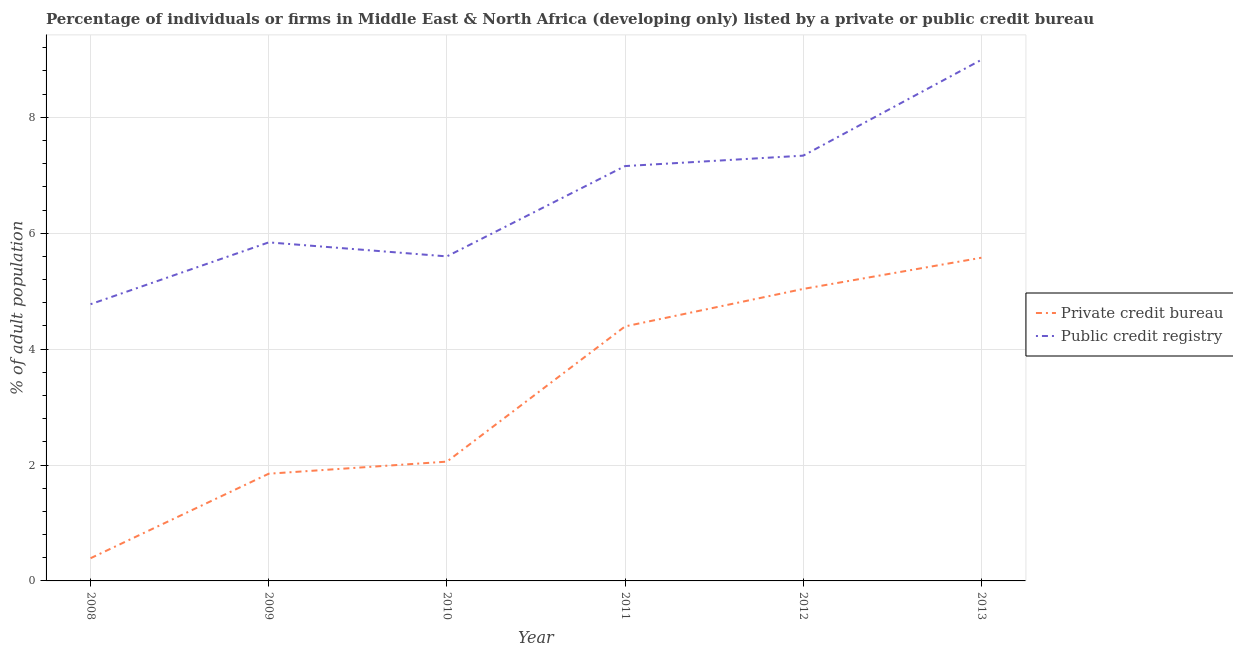How many different coloured lines are there?
Make the answer very short. 2. Is the number of lines equal to the number of legend labels?
Your answer should be compact. Yes. What is the percentage of firms listed by public credit bureau in 2013?
Make the answer very short. 8.99. Across all years, what is the maximum percentage of firms listed by private credit bureau?
Offer a very short reply. 5.58. Across all years, what is the minimum percentage of firms listed by public credit bureau?
Make the answer very short. 4.78. In which year was the percentage of firms listed by private credit bureau maximum?
Your answer should be very brief. 2013. What is the total percentage of firms listed by private credit bureau in the graph?
Make the answer very short. 19.31. What is the difference between the percentage of firms listed by private credit bureau in 2009 and that in 2012?
Offer a terse response. -3.19. What is the difference between the percentage of firms listed by private credit bureau in 2011 and the percentage of firms listed by public credit bureau in 2010?
Your answer should be very brief. -1.21. What is the average percentage of firms listed by private credit bureau per year?
Make the answer very short. 3.22. In the year 2011, what is the difference between the percentage of firms listed by private credit bureau and percentage of firms listed by public credit bureau?
Offer a terse response. -2.77. What is the ratio of the percentage of firms listed by public credit bureau in 2008 to that in 2011?
Ensure brevity in your answer.  0.67. What is the difference between the highest and the second highest percentage of firms listed by public credit bureau?
Give a very brief answer. 1.65. What is the difference between the highest and the lowest percentage of firms listed by private credit bureau?
Your answer should be compact. 5.19. In how many years, is the percentage of firms listed by public credit bureau greater than the average percentage of firms listed by public credit bureau taken over all years?
Provide a succinct answer. 3. How many lines are there?
Your answer should be compact. 2. How many years are there in the graph?
Offer a terse response. 6. Does the graph contain grids?
Your response must be concise. Yes. How many legend labels are there?
Keep it short and to the point. 2. What is the title of the graph?
Offer a terse response. Percentage of individuals or firms in Middle East & North Africa (developing only) listed by a private or public credit bureau. What is the label or title of the Y-axis?
Ensure brevity in your answer.  % of adult population. What is the % of adult population in Private credit bureau in 2008?
Offer a terse response. 0.39. What is the % of adult population in Public credit registry in 2008?
Provide a short and direct response. 4.78. What is the % of adult population in Private credit bureau in 2009?
Give a very brief answer. 1.85. What is the % of adult population in Public credit registry in 2009?
Keep it short and to the point. 5.84. What is the % of adult population of Private credit bureau in 2010?
Give a very brief answer. 2.06. What is the % of adult population of Private credit bureau in 2011?
Offer a terse response. 4.39. What is the % of adult population of Public credit registry in 2011?
Your answer should be compact. 7.16. What is the % of adult population of Private credit bureau in 2012?
Keep it short and to the point. 5.04. What is the % of adult population in Public credit registry in 2012?
Offer a very short reply. 7.34. What is the % of adult population in Private credit bureau in 2013?
Your response must be concise. 5.58. What is the % of adult population in Public credit registry in 2013?
Make the answer very short. 8.99. Across all years, what is the maximum % of adult population in Private credit bureau?
Offer a terse response. 5.58. Across all years, what is the maximum % of adult population in Public credit registry?
Keep it short and to the point. 8.99. Across all years, what is the minimum % of adult population of Private credit bureau?
Make the answer very short. 0.39. Across all years, what is the minimum % of adult population of Public credit registry?
Provide a short and direct response. 4.78. What is the total % of adult population of Private credit bureau in the graph?
Offer a very short reply. 19.31. What is the total % of adult population in Public credit registry in the graph?
Provide a short and direct response. 39.71. What is the difference between the % of adult population in Private credit bureau in 2008 and that in 2009?
Make the answer very short. -1.46. What is the difference between the % of adult population of Public credit registry in 2008 and that in 2009?
Offer a very short reply. -1.07. What is the difference between the % of adult population in Private credit bureau in 2008 and that in 2010?
Make the answer very short. -1.67. What is the difference between the % of adult population of Public credit registry in 2008 and that in 2010?
Provide a short and direct response. -0.82. What is the difference between the % of adult population of Private credit bureau in 2008 and that in 2011?
Your answer should be compact. -4. What is the difference between the % of adult population of Public credit registry in 2008 and that in 2011?
Provide a succinct answer. -2.38. What is the difference between the % of adult population in Private credit bureau in 2008 and that in 2012?
Provide a succinct answer. -4.65. What is the difference between the % of adult population in Public credit registry in 2008 and that in 2012?
Provide a succinct answer. -2.56. What is the difference between the % of adult population of Private credit bureau in 2008 and that in 2013?
Offer a very short reply. -5.19. What is the difference between the % of adult population in Public credit registry in 2008 and that in 2013?
Your response must be concise. -4.22. What is the difference between the % of adult population of Private credit bureau in 2009 and that in 2010?
Offer a very short reply. -0.21. What is the difference between the % of adult population in Public credit registry in 2009 and that in 2010?
Provide a succinct answer. 0.24. What is the difference between the % of adult population in Private credit bureau in 2009 and that in 2011?
Provide a short and direct response. -2.54. What is the difference between the % of adult population of Public credit registry in 2009 and that in 2011?
Your response must be concise. -1.32. What is the difference between the % of adult population in Private credit bureau in 2009 and that in 2012?
Make the answer very short. -3.19. What is the difference between the % of adult population in Public credit registry in 2009 and that in 2012?
Offer a terse response. -1.5. What is the difference between the % of adult population in Private credit bureau in 2009 and that in 2013?
Provide a succinct answer. -3.73. What is the difference between the % of adult population in Public credit registry in 2009 and that in 2013?
Offer a very short reply. -3.15. What is the difference between the % of adult population of Private credit bureau in 2010 and that in 2011?
Your answer should be compact. -2.33. What is the difference between the % of adult population of Public credit registry in 2010 and that in 2011?
Make the answer very short. -1.56. What is the difference between the % of adult population in Private credit bureau in 2010 and that in 2012?
Offer a very short reply. -2.98. What is the difference between the % of adult population in Public credit registry in 2010 and that in 2012?
Your answer should be very brief. -1.74. What is the difference between the % of adult population of Private credit bureau in 2010 and that in 2013?
Your response must be concise. -3.52. What is the difference between the % of adult population in Public credit registry in 2010 and that in 2013?
Provide a short and direct response. -3.39. What is the difference between the % of adult population of Private credit bureau in 2011 and that in 2012?
Make the answer very short. -0.65. What is the difference between the % of adult population of Public credit registry in 2011 and that in 2012?
Give a very brief answer. -0.18. What is the difference between the % of adult population in Private credit bureau in 2011 and that in 2013?
Give a very brief answer. -1.19. What is the difference between the % of adult population of Public credit registry in 2011 and that in 2013?
Offer a terse response. -1.83. What is the difference between the % of adult population of Private credit bureau in 2012 and that in 2013?
Provide a short and direct response. -0.54. What is the difference between the % of adult population of Public credit registry in 2012 and that in 2013?
Make the answer very short. -1.65. What is the difference between the % of adult population of Private credit bureau in 2008 and the % of adult population of Public credit registry in 2009?
Your response must be concise. -5.45. What is the difference between the % of adult population of Private credit bureau in 2008 and the % of adult population of Public credit registry in 2010?
Give a very brief answer. -5.21. What is the difference between the % of adult population of Private credit bureau in 2008 and the % of adult population of Public credit registry in 2011?
Make the answer very short. -6.77. What is the difference between the % of adult population of Private credit bureau in 2008 and the % of adult population of Public credit registry in 2012?
Your answer should be compact. -6.95. What is the difference between the % of adult population of Private credit bureau in 2008 and the % of adult population of Public credit registry in 2013?
Offer a terse response. -8.6. What is the difference between the % of adult population in Private credit bureau in 2009 and the % of adult population in Public credit registry in 2010?
Your answer should be compact. -3.75. What is the difference between the % of adult population of Private credit bureau in 2009 and the % of adult population of Public credit registry in 2011?
Provide a succinct answer. -5.31. What is the difference between the % of adult population in Private credit bureau in 2009 and the % of adult population in Public credit registry in 2012?
Your answer should be very brief. -5.49. What is the difference between the % of adult population in Private credit bureau in 2009 and the % of adult population in Public credit registry in 2013?
Your response must be concise. -7.14. What is the difference between the % of adult population of Private credit bureau in 2010 and the % of adult population of Public credit registry in 2012?
Keep it short and to the point. -5.28. What is the difference between the % of adult population of Private credit bureau in 2010 and the % of adult population of Public credit registry in 2013?
Your answer should be very brief. -6.93. What is the difference between the % of adult population of Private credit bureau in 2011 and the % of adult population of Public credit registry in 2012?
Ensure brevity in your answer.  -2.95. What is the difference between the % of adult population in Private credit bureau in 2011 and the % of adult population in Public credit registry in 2013?
Your response must be concise. -4.6. What is the difference between the % of adult population in Private credit bureau in 2012 and the % of adult population in Public credit registry in 2013?
Provide a succinct answer. -3.95. What is the average % of adult population in Private credit bureau per year?
Keep it short and to the point. 3.22. What is the average % of adult population of Public credit registry per year?
Provide a short and direct response. 6.62. In the year 2008, what is the difference between the % of adult population in Private credit bureau and % of adult population in Public credit registry?
Provide a succinct answer. -4.38. In the year 2009, what is the difference between the % of adult population of Private credit bureau and % of adult population of Public credit registry?
Ensure brevity in your answer.  -3.99. In the year 2010, what is the difference between the % of adult population of Private credit bureau and % of adult population of Public credit registry?
Give a very brief answer. -3.54. In the year 2011, what is the difference between the % of adult population in Private credit bureau and % of adult population in Public credit registry?
Offer a very short reply. -2.77. In the year 2012, what is the difference between the % of adult population of Private credit bureau and % of adult population of Public credit registry?
Your answer should be very brief. -2.3. In the year 2013, what is the difference between the % of adult population of Private credit bureau and % of adult population of Public credit registry?
Provide a succinct answer. -3.42. What is the ratio of the % of adult population in Private credit bureau in 2008 to that in 2009?
Give a very brief answer. 0.21. What is the ratio of the % of adult population in Public credit registry in 2008 to that in 2009?
Keep it short and to the point. 0.82. What is the ratio of the % of adult population in Private credit bureau in 2008 to that in 2010?
Your answer should be compact. 0.19. What is the ratio of the % of adult population in Public credit registry in 2008 to that in 2010?
Your response must be concise. 0.85. What is the ratio of the % of adult population of Private credit bureau in 2008 to that in 2011?
Offer a terse response. 0.09. What is the ratio of the % of adult population of Public credit registry in 2008 to that in 2011?
Offer a terse response. 0.67. What is the ratio of the % of adult population in Private credit bureau in 2008 to that in 2012?
Ensure brevity in your answer.  0.08. What is the ratio of the % of adult population of Public credit registry in 2008 to that in 2012?
Your answer should be very brief. 0.65. What is the ratio of the % of adult population in Private credit bureau in 2008 to that in 2013?
Make the answer very short. 0.07. What is the ratio of the % of adult population of Public credit registry in 2008 to that in 2013?
Offer a terse response. 0.53. What is the ratio of the % of adult population of Private credit bureau in 2009 to that in 2010?
Offer a very short reply. 0.9. What is the ratio of the % of adult population in Public credit registry in 2009 to that in 2010?
Offer a terse response. 1.04. What is the ratio of the % of adult population of Private credit bureau in 2009 to that in 2011?
Offer a terse response. 0.42. What is the ratio of the % of adult population in Public credit registry in 2009 to that in 2011?
Your answer should be compact. 0.82. What is the ratio of the % of adult population in Private credit bureau in 2009 to that in 2012?
Provide a short and direct response. 0.37. What is the ratio of the % of adult population of Public credit registry in 2009 to that in 2012?
Keep it short and to the point. 0.8. What is the ratio of the % of adult population of Private credit bureau in 2009 to that in 2013?
Provide a short and direct response. 0.33. What is the ratio of the % of adult population in Public credit registry in 2009 to that in 2013?
Offer a terse response. 0.65. What is the ratio of the % of adult population in Private credit bureau in 2010 to that in 2011?
Make the answer very short. 0.47. What is the ratio of the % of adult population in Public credit registry in 2010 to that in 2011?
Provide a short and direct response. 0.78. What is the ratio of the % of adult population of Private credit bureau in 2010 to that in 2012?
Keep it short and to the point. 0.41. What is the ratio of the % of adult population in Public credit registry in 2010 to that in 2012?
Keep it short and to the point. 0.76. What is the ratio of the % of adult population of Private credit bureau in 2010 to that in 2013?
Give a very brief answer. 0.37. What is the ratio of the % of adult population of Public credit registry in 2010 to that in 2013?
Keep it short and to the point. 0.62. What is the ratio of the % of adult population of Private credit bureau in 2011 to that in 2012?
Provide a succinct answer. 0.87. What is the ratio of the % of adult population of Public credit registry in 2011 to that in 2012?
Offer a terse response. 0.98. What is the ratio of the % of adult population of Private credit bureau in 2011 to that in 2013?
Make the answer very short. 0.79. What is the ratio of the % of adult population of Public credit registry in 2011 to that in 2013?
Give a very brief answer. 0.8. What is the ratio of the % of adult population of Private credit bureau in 2012 to that in 2013?
Give a very brief answer. 0.9. What is the ratio of the % of adult population in Public credit registry in 2012 to that in 2013?
Your response must be concise. 0.82. What is the difference between the highest and the second highest % of adult population in Private credit bureau?
Your answer should be very brief. 0.54. What is the difference between the highest and the second highest % of adult population in Public credit registry?
Give a very brief answer. 1.65. What is the difference between the highest and the lowest % of adult population in Private credit bureau?
Your response must be concise. 5.19. What is the difference between the highest and the lowest % of adult population in Public credit registry?
Ensure brevity in your answer.  4.22. 